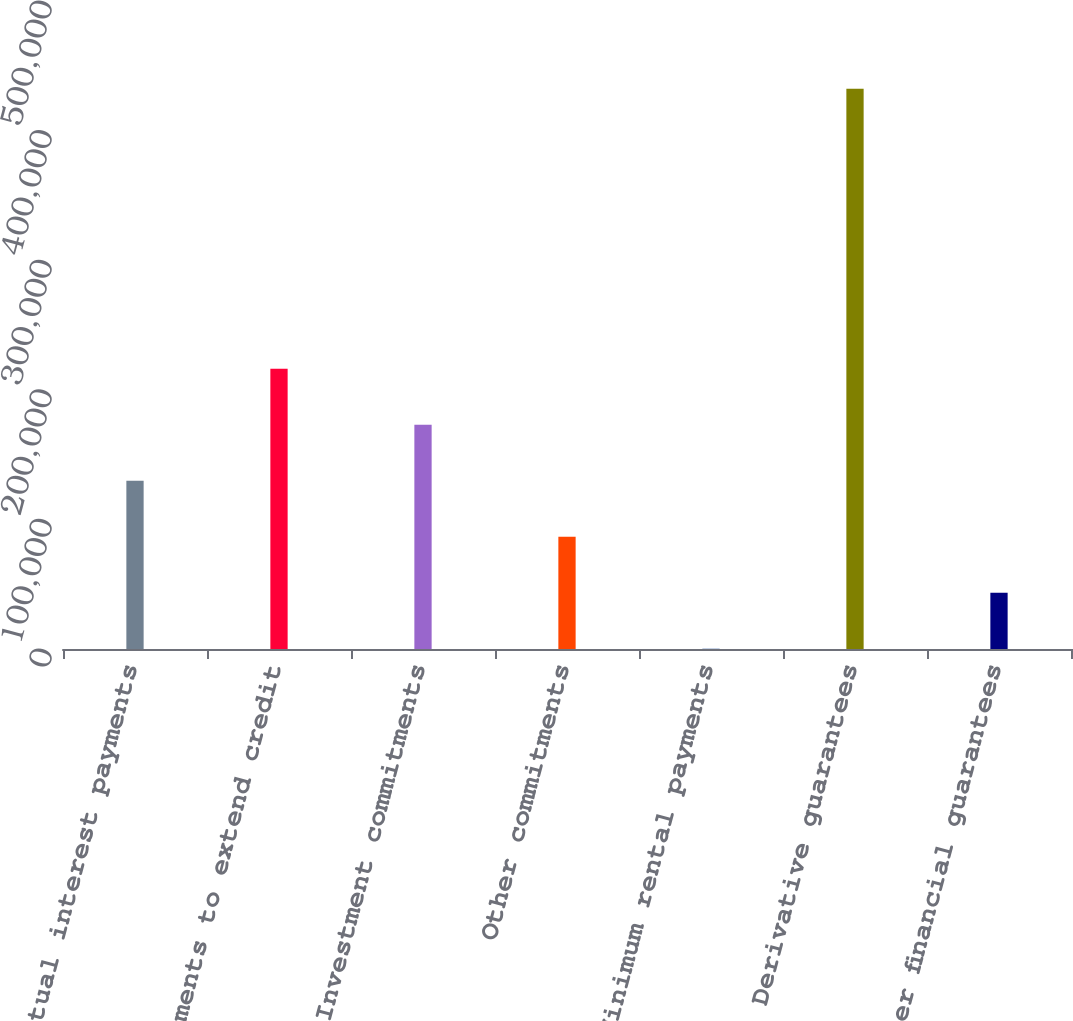Convert chart. <chart><loc_0><loc_0><loc_500><loc_500><bar_chart><fcel>Contractual interest payments<fcel>Commitments to extend credit<fcel>Investment commitments<fcel>Other commitments<fcel>Minimum rental payments<fcel>Derivative guarantees<fcel>Other financial guarantees<nl><fcel>129901<fcel>216309<fcel>173105<fcel>86697.6<fcel>290<fcel>432328<fcel>43493.8<nl></chart> 